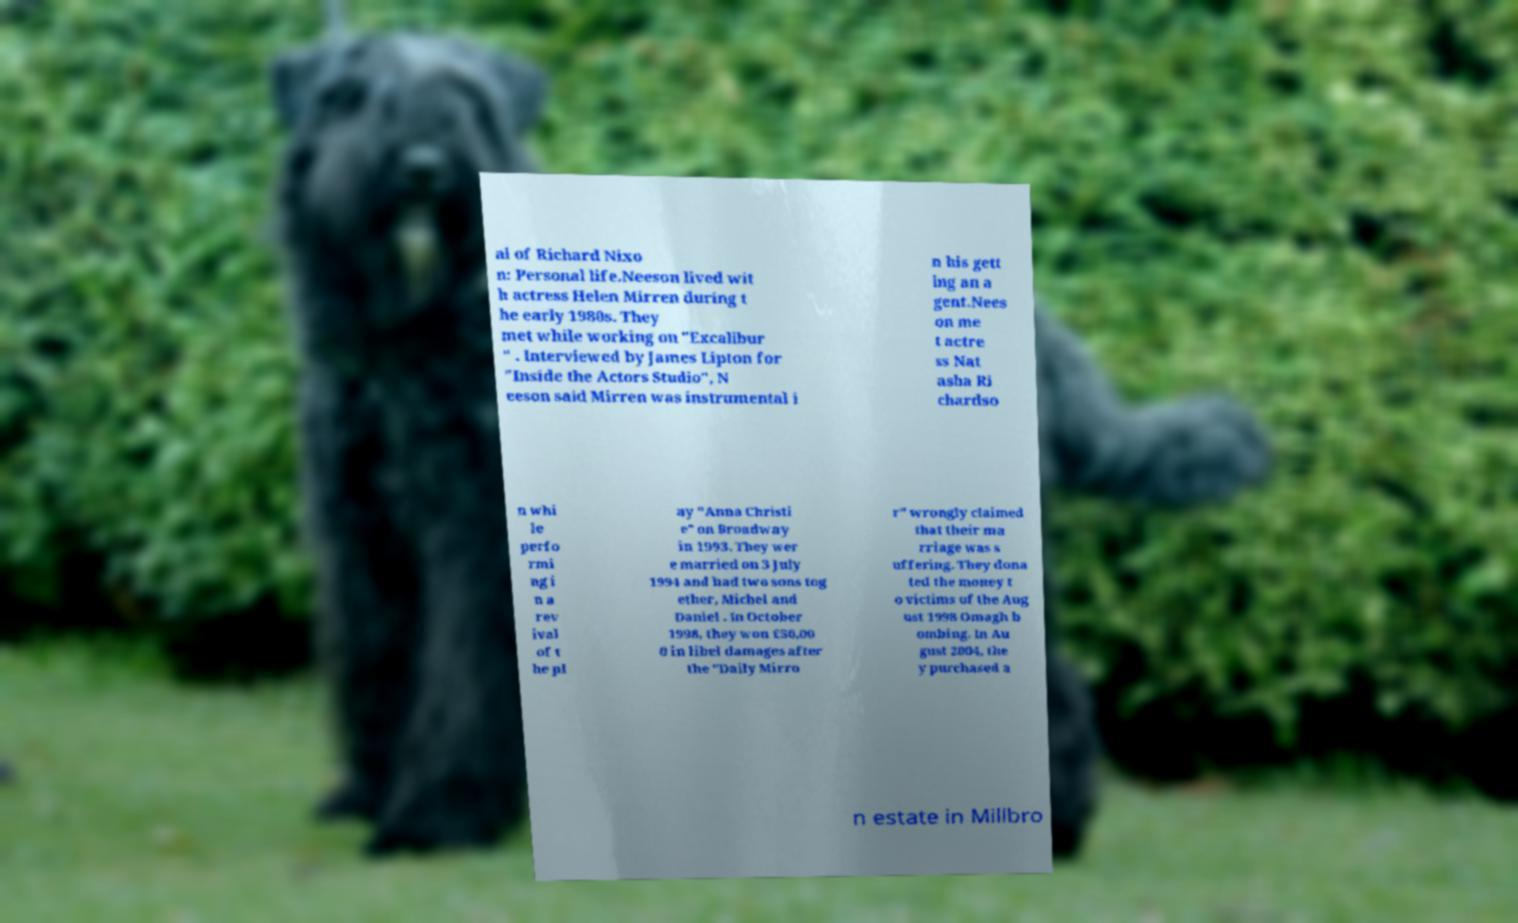What messages or text are displayed in this image? I need them in a readable, typed format. al of Richard Nixo n: Personal life.Neeson lived wit h actress Helen Mirren during t he early 1980s. They met while working on "Excalibur " . Interviewed by James Lipton for "Inside the Actors Studio", N eeson said Mirren was instrumental i n his gett ing an a gent.Nees on me t actre ss Nat asha Ri chardso n whi le perfo rmi ng i n a rev ival of t he pl ay "Anna Christi e" on Broadway in 1993. They wer e married on 3 July 1994 and had two sons tog ether, Michel and Daniel . In October 1998, they won £50,00 0 in libel damages after the "Daily Mirro r" wrongly claimed that their ma rriage was s uffering. They dona ted the money t o victims of the Aug ust 1998 Omagh b ombing. In Au gust 2004, the y purchased a n estate in Millbro 